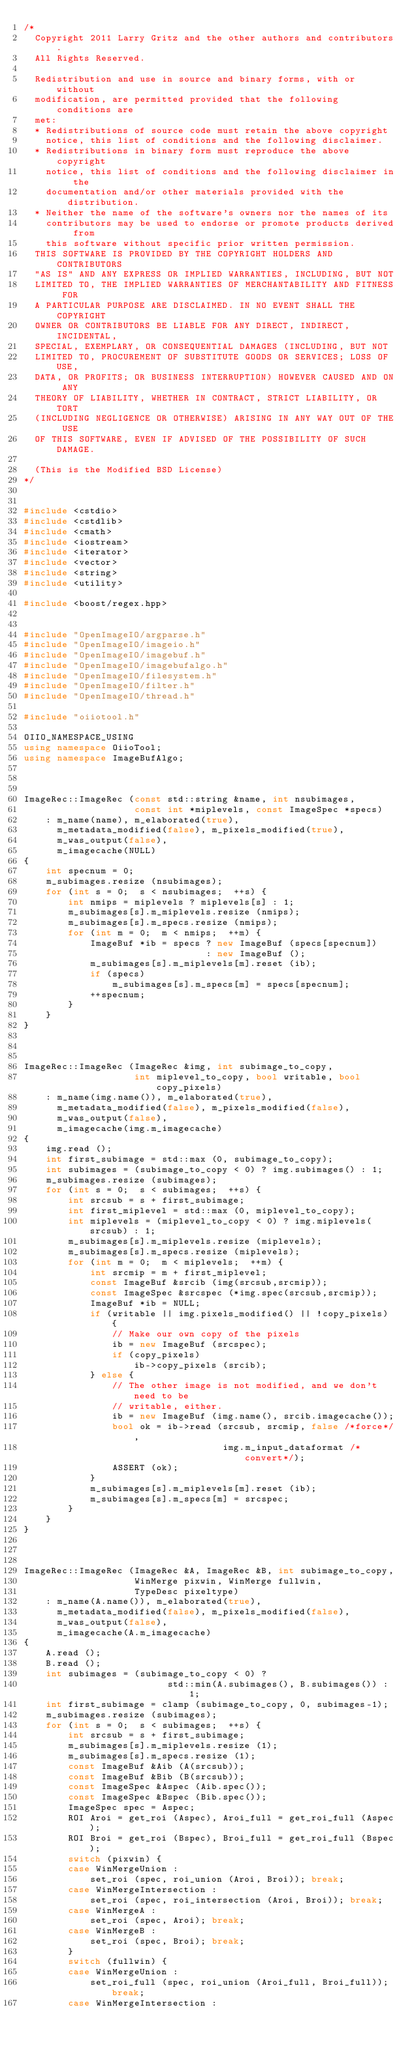<code> <loc_0><loc_0><loc_500><loc_500><_C++_>/*
  Copyright 2011 Larry Gritz and the other authors and contributors.
  All Rights Reserved.

  Redistribution and use in source and binary forms, with or without
  modification, are permitted provided that the following conditions are
  met:
  * Redistributions of source code must retain the above copyright
    notice, this list of conditions and the following disclaimer.
  * Redistributions in binary form must reproduce the above copyright
    notice, this list of conditions and the following disclaimer in the
    documentation and/or other materials provided with the distribution.
  * Neither the name of the software's owners nor the names of its
    contributors may be used to endorse or promote products derived from
    this software without specific prior written permission.
  THIS SOFTWARE IS PROVIDED BY THE COPYRIGHT HOLDERS AND CONTRIBUTORS
  "AS IS" AND ANY EXPRESS OR IMPLIED WARRANTIES, INCLUDING, BUT NOT
  LIMITED TO, THE IMPLIED WARRANTIES OF MERCHANTABILITY AND FITNESS FOR
  A PARTICULAR PURPOSE ARE DISCLAIMED. IN NO EVENT SHALL THE COPYRIGHT
  OWNER OR CONTRIBUTORS BE LIABLE FOR ANY DIRECT, INDIRECT, INCIDENTAL,
  SPECIAL, EXEMPLARY, OR CONSEQUENTIAL DAMAGES (INCLUDING, BUT NOT
  LIMITED TO, PROCUREMENT OF SUBSTITUTE GOODS OR SERVICES; LOSS OF USE,
  DATA, OR PROFITS; OR BUSINESS INTERRUPTION) HOWEVER CAUSED AND ON ANY
  THEORY OF LIABILITY, WHETHER IN CONTRACT, STRICT LIABILITY, OR TORT
  (INCLUDING NEGLIGENCE OR OTHERWISE) ARISING IN ANY WAY OUT OF THE USE
  OF THIS SOFTWARE, EVEN IF ADVISED OF THE POSSIBILITY OF SUCH DAMAGE.

  (This is the Modified BSD License)
*/


#include <cstdio>
#include <cstdlib>
#include <cmath>
#include <iostream>
#include <iterator>
#include <vector>
#include <string>
#include <utility>

#include <boost/regex.hpp>


#include "OpenImageIO/argparse.h"
#include "OpenImageIO/imageio.h"
#include "OpenImageIO/imagebuf.h"
#include "OpenImageIO/imagebufalgo.h"
#include "OpenImageIO/filesystem.h"
#include "OpenImageIO/filter.h"
#include "OpenImageIO/thread.h"

#include "oiiotool.h"

OIIO_NAMESPACE_USING
using namespace OiioTool;
using namespace ImageBufAlgo;



ImageRec::ImageRec (const std::string &name, int nsubimages,
                    const int *miplevels, const ImageSpec *specs)
    : m_name(name), m_elaborated(true),
      m_metadata_modified(false), m_pixels_modified(true),
      m_was_output(false),
      m_imagecache(NULL)
{
    int specnum = 0;
    m_subimages.resize (nsubimages);
    for (int s = 0;  s < nsubimages;  ++s) {
        int nmips = miplevels ? miplevels[s] : 1;
        m_subimages[s].m_miplevels.resize (nmips);
        m_subimages[s].m_specs.resize (nmips);
        for (int m = 0;  m < nmips;  ++m) {
            ImageBuf *ib = specs ? new ImageBuf (specs[specnum])
                                 : new ImageBuf ();
            m_subimages[s].m_miplevels[m].reset (ib);
            if (specs)
                m_subimages[s].m_specs[m] = specs[specnum];
            ++specnum;
        }
    }
}



ImageRec::ImageRec (ImageRec &img, int subimage_to_copy,
                    int miplevel_to_copy, bool writable, bool copy_pixels)
    : m_name(img.name()), m_elaborated(true),
      m_metadata_modified(false), m_pixels_modified(false),
      m_was_output(false),
      m_imagecache(img.m_imagecache)
{
    img.read ();
    int first_subimage = std::max (0, subimage_to_copy);
    int subimages = (subimage_to_copy < 0) ? img.subimages() : 1;
    m_subimages.resize (subimages);
    for (int s = 0;  s < subimages;  ++s) {
        int srcsub = s + first_subimage;
        int first_miplevel = std::max (0, miplevel_to_copy);
        int miplevels = (miplevel_to_copy < 0) ? img.miplevels(srcsub) : 1;
        m_subimages[s].m_miplevels.resize (miplevels);
        m_subimages[s].m_specs.resize (miplevels);
        for (int m = 0;  m < miplevels;  ++m) {
            int srcmip = m + first_miplevel;
            const ImageBuf &srcib (img(srcsub,srcmip));
            const ImageSpec &srcspec (*img.spec(srcsub,srcmip));
            ImageBuf *ib = NULL;
            if (writable || img.pixels_modified() || !copy_pixels) {
                // Make our own copy of the pixels
                ib = new ImageBuf (srcspec);
                if (copy_pixels)
                    ib->copy_pixels (srcib);
            } else {
                // The other image is not modified, and we don't need to be
                // writable, either.
                ib = new ImageBuf (img.name(), srcib.imagecache());
                bool ok = ib->read (srcsub, srcmip, false /*force*/,
                                    img.m_input_dataformat /*convert*/);
                ASSERT (ok);
            }
            m_subimages[s].m_miplevels[m].reset (ib);
            m_subimages[s].m_specs[m] = srcspec;
        }
    }
}



ImageRec::ImageRec (ImageRec &A, ImageRec &B, int subimage_to_copy,
                    WinMerge pixwin, WinMerge fullwin,
                    TypeDesc pixeltype)
    : m_name(A.name()), m_elaborated(true),
      m_metadata_modified(false), m_pixels_modified(false),
      m_was_output(false),
      m_imagecache(A.m_imagecache)
{
    A.read ();
    B.read ();
    int subimages = (subimage_to_copy < 0) ? 
                          std::min(A.subimages(), B.subimages()) : 1;
    int first_subimage = clamp (subimage_to_copy, 0, subimages-1);
    m_subimages.resize (subimages);
    for (int s = 0;  s < subimages;  ++s) {
        int srcsub = s + first_subimage;
        m_subimages[s].m_miplevels.resize (1);
        m_subimages[s].m_specs.resize (1);
        const ImageBuf &Aib (A(srcsub));
        const ImageBuf &Bib (B(srcsub));
        const ImageSpec &Aspec (Aib.spec());
        const ImageSpec &Bspec (Bib.spec());
        ImageSpec spec = Aspec;
        ROI Aroi = get_roi (Aspec), Aroi_full = get_roi_full (Aspec);
        ROI Broi = get_roi (Bspec), Broi_full = get_roi_full (Bspec);
        switch (pixwin) {
        case WinMergeUnion :
            set_roi (spec, roi_union (Aroi, Broi)); break;
        case WinMergeIntersection :
            set_roi (spec, roi_intersection (Aroi, Broi)); break;
        case WinMergeA :
            set_roi (spec, Aroi); break;
        case WinMergeB :
            set_roi (spec, Broi); break;
        }
        switch (fullwin) {
        case WinMergeUnion :
            set_roi_full (spec, roi_union (Aroi_full, Broi_full)); break;
        case WinMergeIntersection :</code> 